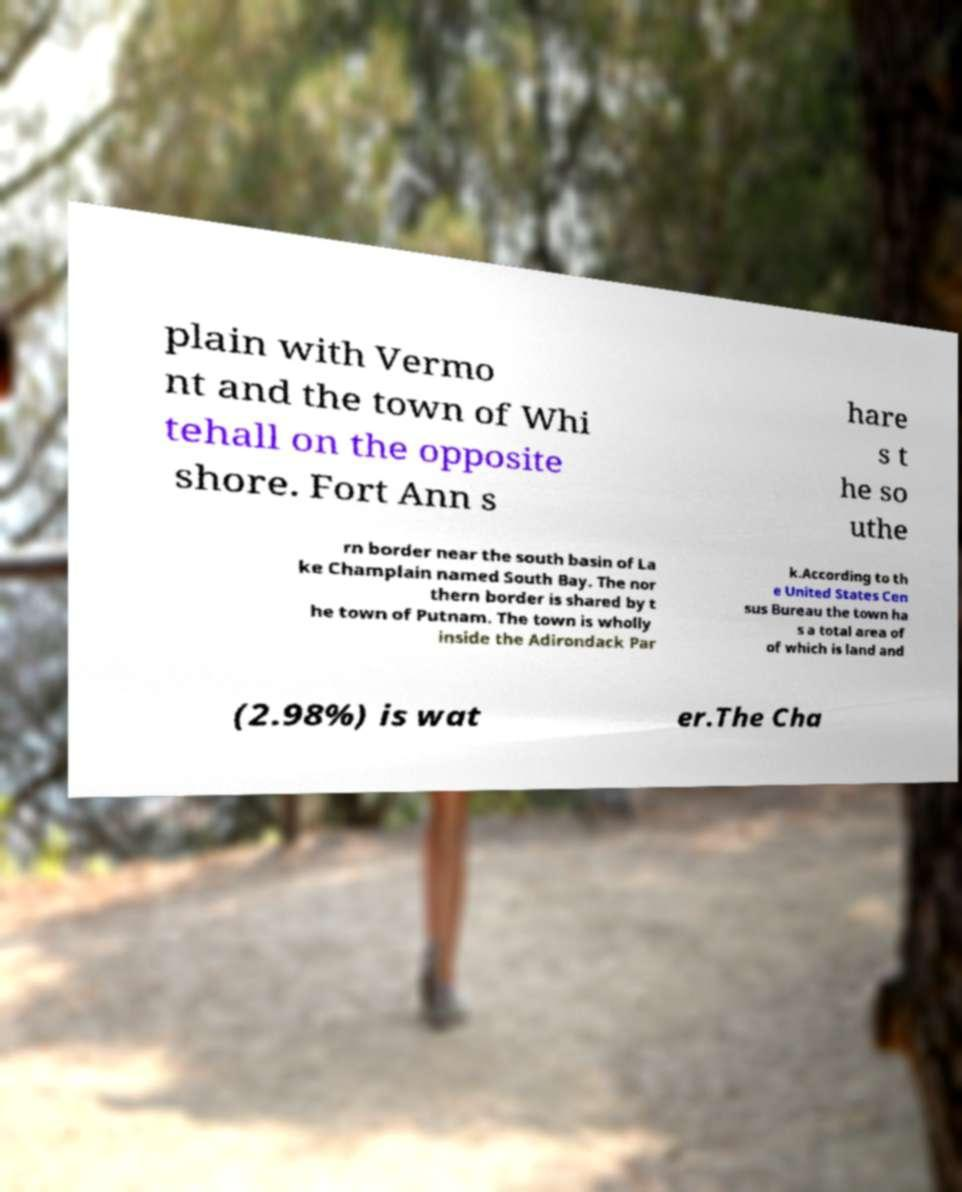There's text embedded in this image that I need extracted. Can you transcribe it verbatim? plain with Vermo nt and the town of Whi tehall on the opposite shore. Fort Ann s hare s t he so uthe rn border near the south basin of La ke Champlain named South Bay. The nor thern border is shared by t he town of Putnam. The town is wholly inside the Adirondack Par k.According to th e United States Cen sus Bureau the town ha s a total area of of which is land and (2.98%) is wat er.The Cha 